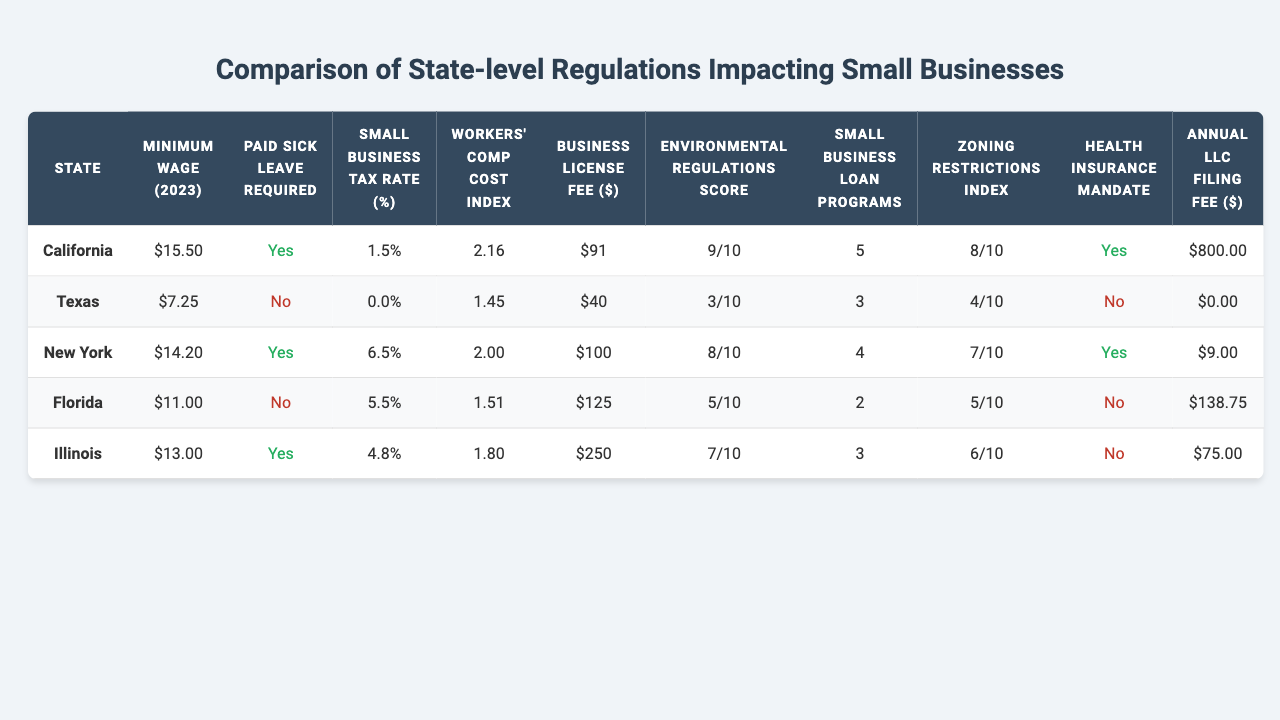What is the minimum wage in California for 2023? The minimum wage for California is listed in the table as $15.50.
Answer: $15.50 Which state has the highest business license fee? The business license fees for each state are listed: California ($91), Texas ($40), New York ($100), Florida ($125), and Illinois ($250). Illinois has the highest fee of $250.
Answer: Illinois Does Texas require paid sick leave for small businesses? The table indicates whether paid sick leave is required, and for Texas, it shows 'No'.
Answer: No What is the small business tax rate in New York? The small business tax rate for New York is provided in the table as 6.5%.
Answer: 6.5% Which state has the lowest annual LLC filing fee? The annual LLC filing fees are listed for each state: California ($800), Texas ($0), New York ($9), Florida ($138.75), and Illinois ($75). Texas has the lowest fee at $0.
Answer: Texas What is the difference in the workers' compensation cost index between California and Florida? The workers' comp cost index for California is 2.16 and for Florida is 1.51. The difference is 2.16 - 1.51 = 0.65.
Answer: 0.65 How many small business loan programs are available in Florida? The number of small business loan programs for Florida is shown in the table as 2.
Answer: 2 How many states require a health insurance mandate? The table shows health insurance mandates for each state: California (Yes), Texas (No), New York (Yes), Florida (No), and Illinois (No). Thus three states (California and New York) require it.
Answer: 2 What is the average small business tax rate across the listed states? The small business tax rates are: 1.5% (California), 0.0% (Texas), 6.5% (New York), 5.5% (Florida), and 4.8% (Illinois). The average is (1.5 + 0 + 6.5 + 5.5 + 4.8) / 5 = 3.64%.
Answer: 3.64% Which state has the highest environmental regulations score? The environmental regulations scores are: California (9), Texas (3), New York (8), Florida (5), Illinois (7). California has the highest score of 9.
Answer: California How does the workers' compensation cost index of Illinois compare to Texas? The workers' comp cost index for Illinois is 1.80, while for Texas it is 1.45. The higher index indicates that Illinois has a higher cost by 1.80 - 1.45 = 0.35.
Answer: 0.35 higher in Illinois What is the total number of small business loan programs available in California and New York combined? The number of small business loan programs for California is 5 and for New York is 4. The total is 5 + 4 = 9.
Answer: 9 